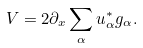<formula> <loc_0><loc_0><loc_500><loc_500>V = 2 \partial _ { x } \sum _ { \alpha } u _ { \alpha } ^ { * } g _ { \alpha } .</formula> 